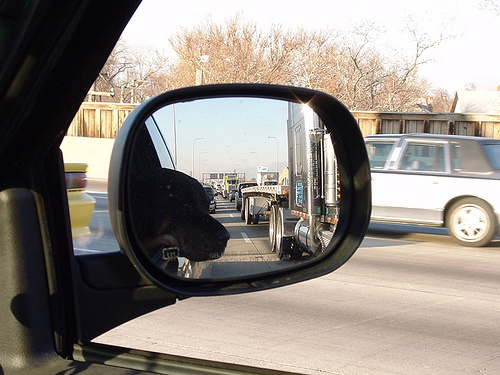Describe the objects in this image and their specific colors. I can see car in black, lightgray, gray, and darkgray tones, car in black, white, darkgray, and gray tones, truck in black, gray, white, and darkgray tones, dog in black, gray, darkgray, and lightgray tones, and car in black, tan, darkgray, and gray tones in this image. 